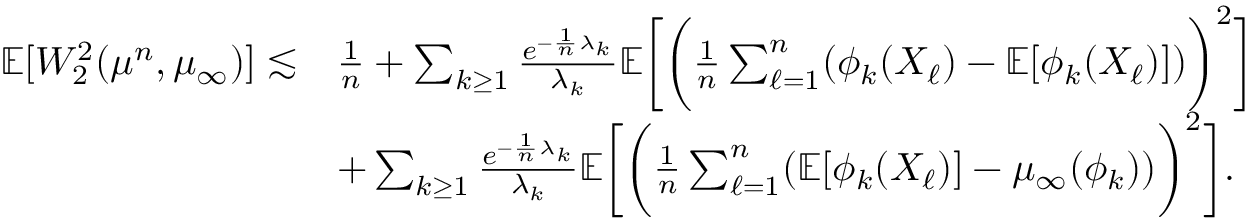<formula> <loc_0><loc_0><loc_500><loc_500>\begin{array} { r l } { \mathbb { E } [ W _ { 2 } ^ { 2 } ( \mu ^ { n } , \mu _ { \infty } ) ] \lesssim } & { \frac { 1 } { n } + \sum _ { k \geq 1 } \frac { e ^ { - \frac { 1 } { n } \lambda _ { k } } } { \lambda _ { k } } \mathbb { E } \left [ \left ( \frac { 1 } { n } \sum _ { \ell = 1 } ^ { n } ( \phi _ { k } ( X _ { \ell } ) - \mathbb { E } [ \phi _ { k } ( X _ { \ell } ) ] ) \right ) ^ { 2 } \right ] } \\ & { + \sum _ { k \geq 1 } \frac { e ^ { - \frac { 1 } { n } \lambda _ { k } } } { \lambda _ { k } } \mathbb { E } \left [ \left ( \frac { 1 } { n } \sum _ { \ell = 1 } ^ { n } ( \mathbb { E } [ \phi _ { k } ( X _ { \ell } ) ] - \mu _ { \infty } ( \phi _ { k } ) ) \right ) ^ { 2 } \right ] . } \end{array}</formula> 